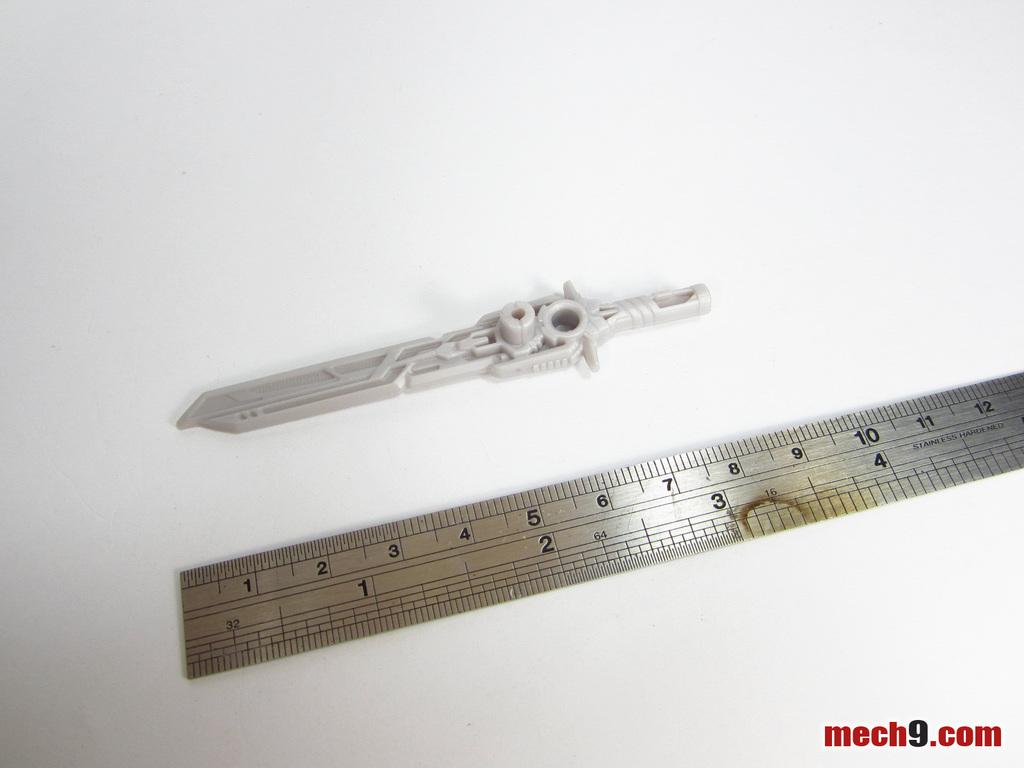Provide a one-sentence caption for the provided image. A plastic sword on a white background measuring three inches on a ruler below it. 